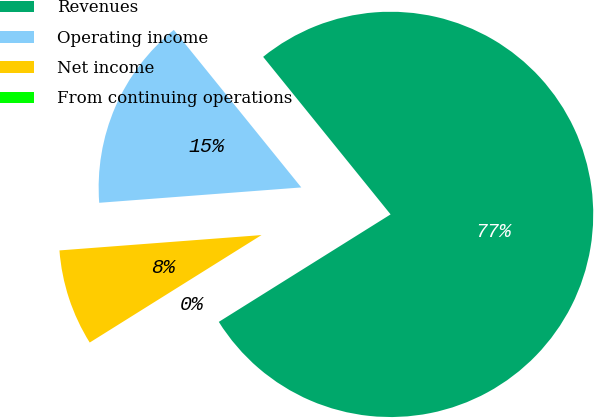Convert chart to OTSL. <chart><loc_0><loc_0><loc_500><loc_500><pie_chart><fcel>Revenues<fcel>Operating income<fcel>Net income<fcel>From continuing operations<nl><fcel>76.92%<fcel>15.38%<fcel>7.69%<fcel>0.0%<nl></chart> 